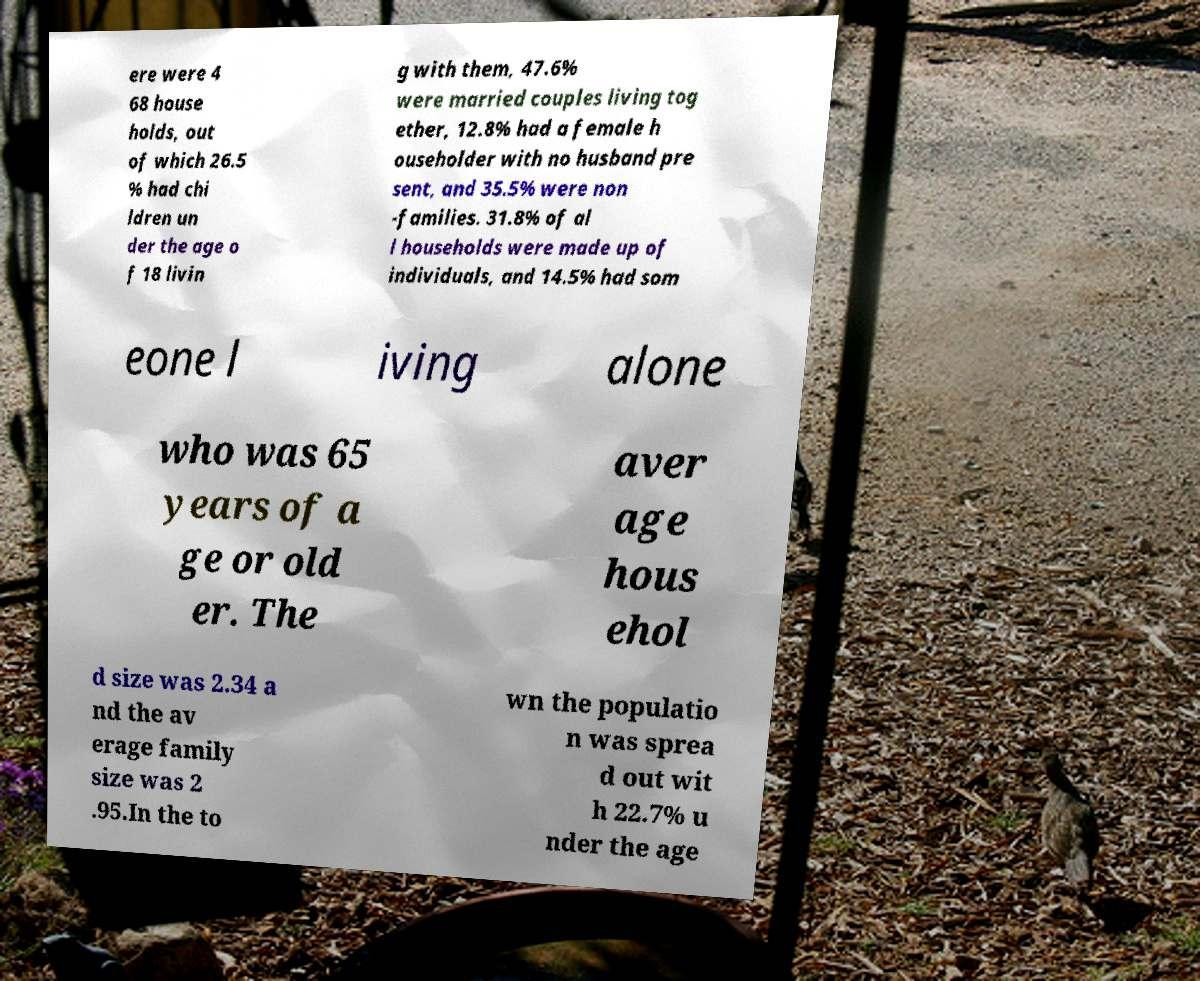For documentation purposes, I need the text within this image transcribed. Could you provide that? ere were 4 68 house holds, out of which 26.5 % had chi ldren un der the age o f 18 livin g with them, 47.6% were married couples living tog ether, 12.8% had a female h ouseholder with no husband pre sent, and 35.5% were non -families. 31.8% of al l households were made up of individuals, and 14.5% had som eone l iving alone who was 65 years of a ge or old er. The aver age hous ehol d size was 2.34 a nd the av erage family size was 2 .95.In the to wn the populatio n was sprea d out wit h 22.7% u nder the age 